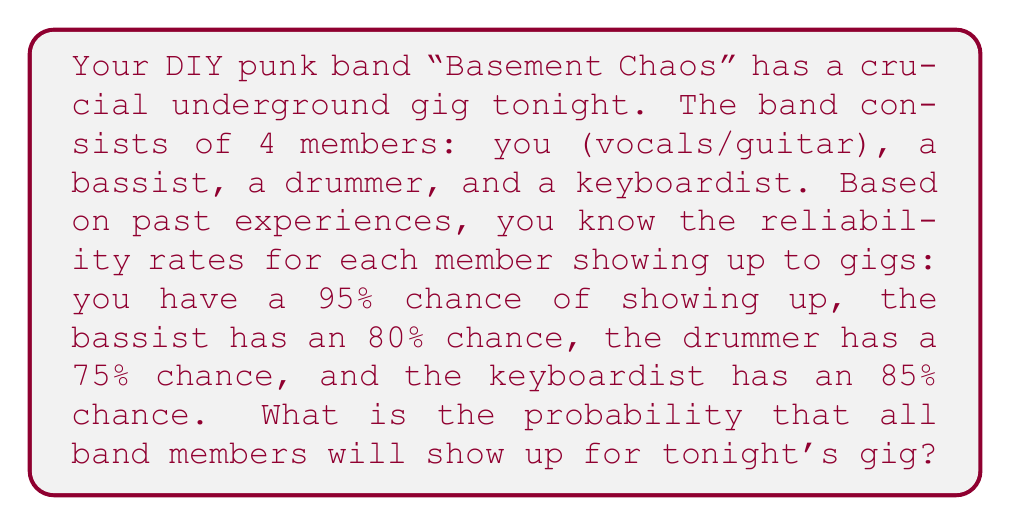What is the answer to this math problem? Let's approach this step-by-step:

1) First, we need to understand that for all band members to show up, each individual member must show up. In probability terms, this is an "and" scenario.

2) When we have independent events that all need to occur, we multiply the individual probabilities.

3) Let's define our events:
   A = You show up (95% or 0.95)
   B = Bassist shows up (80% or 0.80)
   C = Drummer shows up (75% or 0.75)
   D = Keyboardist shows up (85% or 0.85)

4) We want to find P(A and B and C and D)

5) Given that these are independent events, we can calculate this as:
   
   $$P(A \text{ and } B \text{ and } C \text{ and } D) = P(A) \times P(B) \times P(C) \times P(D)$$

6) Substituting the values:

   $$P(\text{All show up}) = 0.95 \times 0.80 \times 0.75 \times 0.85$$

7) Calculating:

   $$P(\text{All show up}) = 0.4845 = 48.45\%$$

Therefore, the probability that all band members will show up for tonight's gig is approximately 48.45%.
Answer: $0.4845$ or $48.45\%$ 